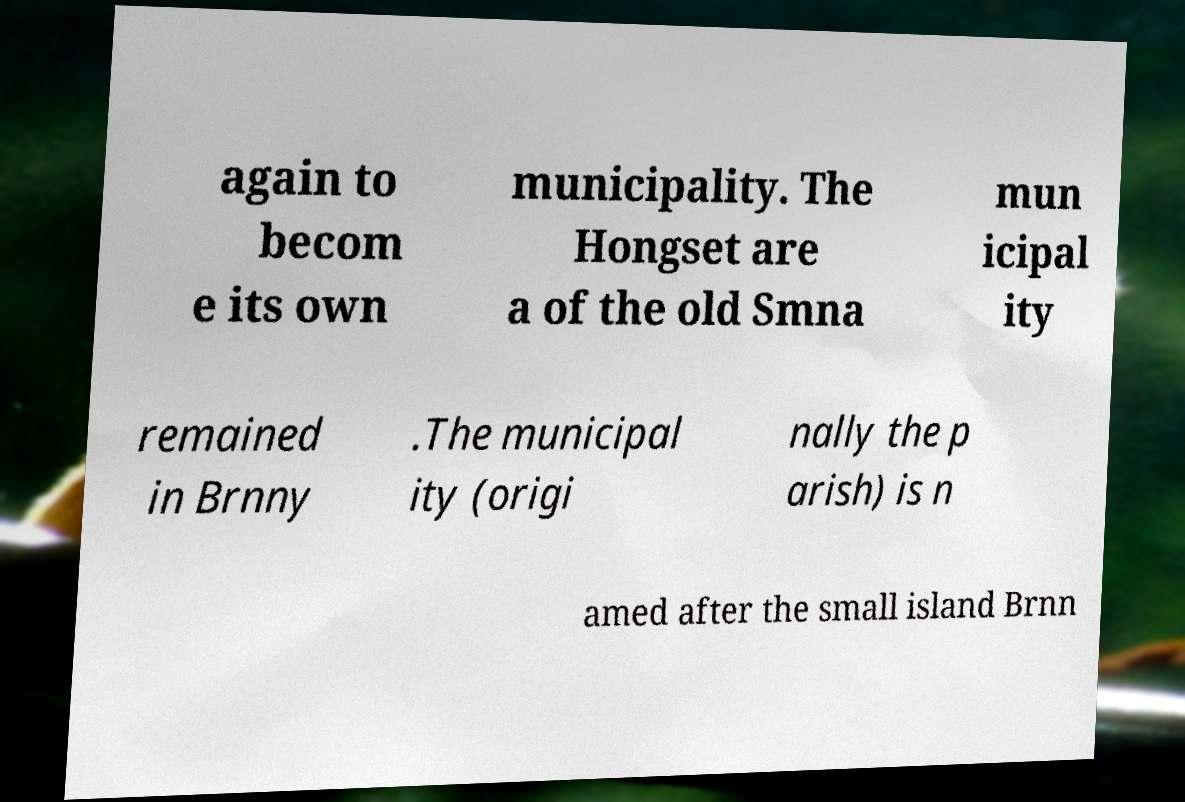Could you extract and type out the text from this image? again to becom e its own municipality. The Hongset are a of the old Smna mun icipal ity remained in Brnny .The municipal ity (origi nally the p arish) is n amed after the small island Brnn 